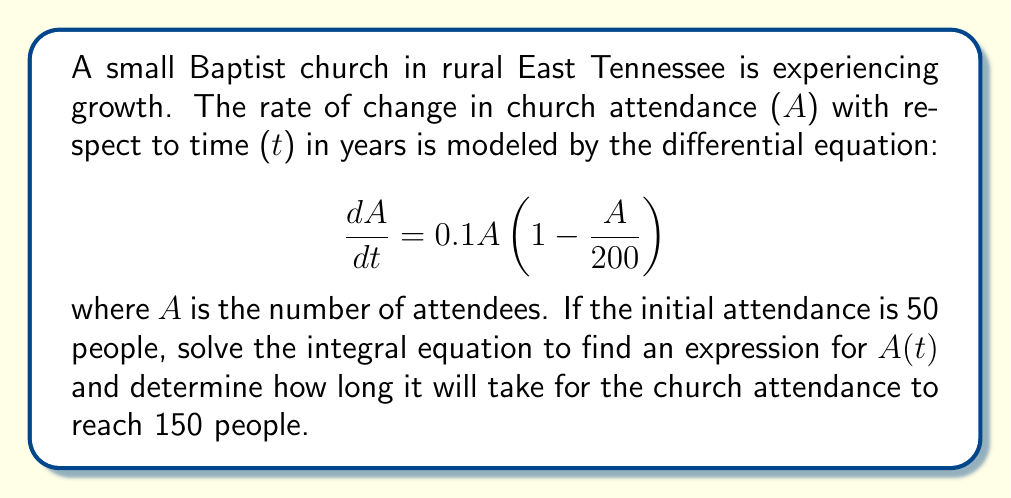Solve this math problem. 1) First, we need to separate variables and integrate both sides:

   $$\int \frac{dA}{A(1-\frac{A}{200})} = \int 0.1 dt$$

2) The left side can be integrated using partial fractions:

   $$\int \frac{dA}{A} + \int \frac{dA}{200-A} = 0.1t + C$$

3) Evaluating these integrals:

   $$\ln|A| - \ln|200-A| = 0.1t + C$$

4) Simplifying:

   $$\ln|\frac{A}{200-A}| = 0.1t + C$$

5) Exponentiating both sides:

   $$\frac{A}{200-A} = e^{0.1t + C} = Ke^{0.1t}$$

   where $K = e^C$

6) Solving for A:

   $$A = \frac{200Ke^{0.1t}}{1+Ke^{0.1t}}$$

7) Using the initial condition A(0) = 50:

   $$50 = \frac{200K}{1+K}$$

   Solving for K: $K = \frac{1}{3}$

8) Therefore, the solution is:

   $$A(t) = \frac{200(\frac{1}{3})e^{0.1t}}{1+(\frac{1}{3})e^{0.1t}} = \frac{200}{3e^{-0.1t}+1}$$

9) To find when A(t) = 150:

   $$150 = \frac{200}{3e^{-0.1t}+1}$$

   Solving for t:

   $$t = -10\ln(\frac{1}{9}) \approx 21.97$$
Answer: $A(t) = \frac{200}{3e^{-0.1t}+1}$; approximately 21.97 years 